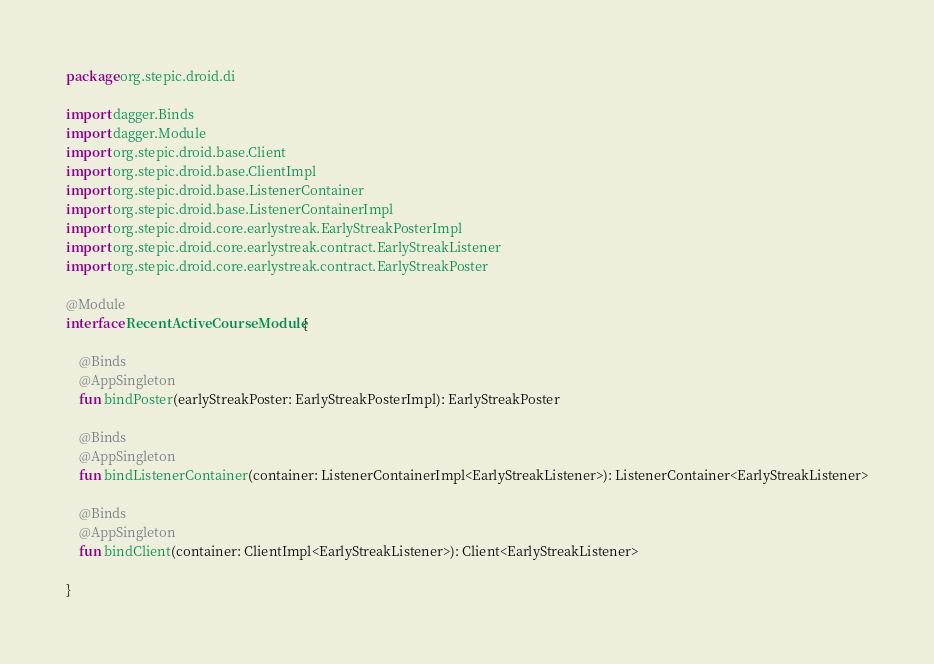Convert code to text. <code><loc_0><loc_0><loc_500><loc_500><_Kotlin_>package org.stepic.droid.di

import dagger.Binds
import dagger.Module
import org.stepic.droid.base.Client
import org.stepic.droid.base.ClientImpl
import org.stepic.droid.base.ListenerContainer
import org.stepic.droid.base.ListenerContainerImpl
import org.stepic.droid.core.earlystreak.EarlyStreakPosterImpl
import org.stepic.droid.core.earlystreak.contract.EarlyStreakListener
import org.stepic.droid.core.earlystreak.contract.EarlyStreakPoster

@Module
interface RecentActiveCourseModule {

    @Binds
    @AppSingleton
    fun bindPoster(earlyStreakPoster: EarlyStreakPosterImpl): EarlyStreakPoster

    @Binds
    @AppSingleton
    fun bindListenerContainer(container: ListenerContainerImpl<EarlyStreakListener>): ListenerContainer<EarlyStreakListener>

    @Binds
    @AppSingleton
    fun bindClient(container: ClientImpl<EarlyStreakListener>): Client<EarlyStreakListener>

}
</code> 